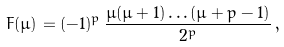<formula> <loc_0><loc_0><loc_500><loc_500>F ( \mu ) = ( - 1 ) ^ { p } \, \frac { \mu ( \mu + 1 ) \dots ( \mu + p - 1 ) } { 2 ^ { p } } \, ,</formula> 